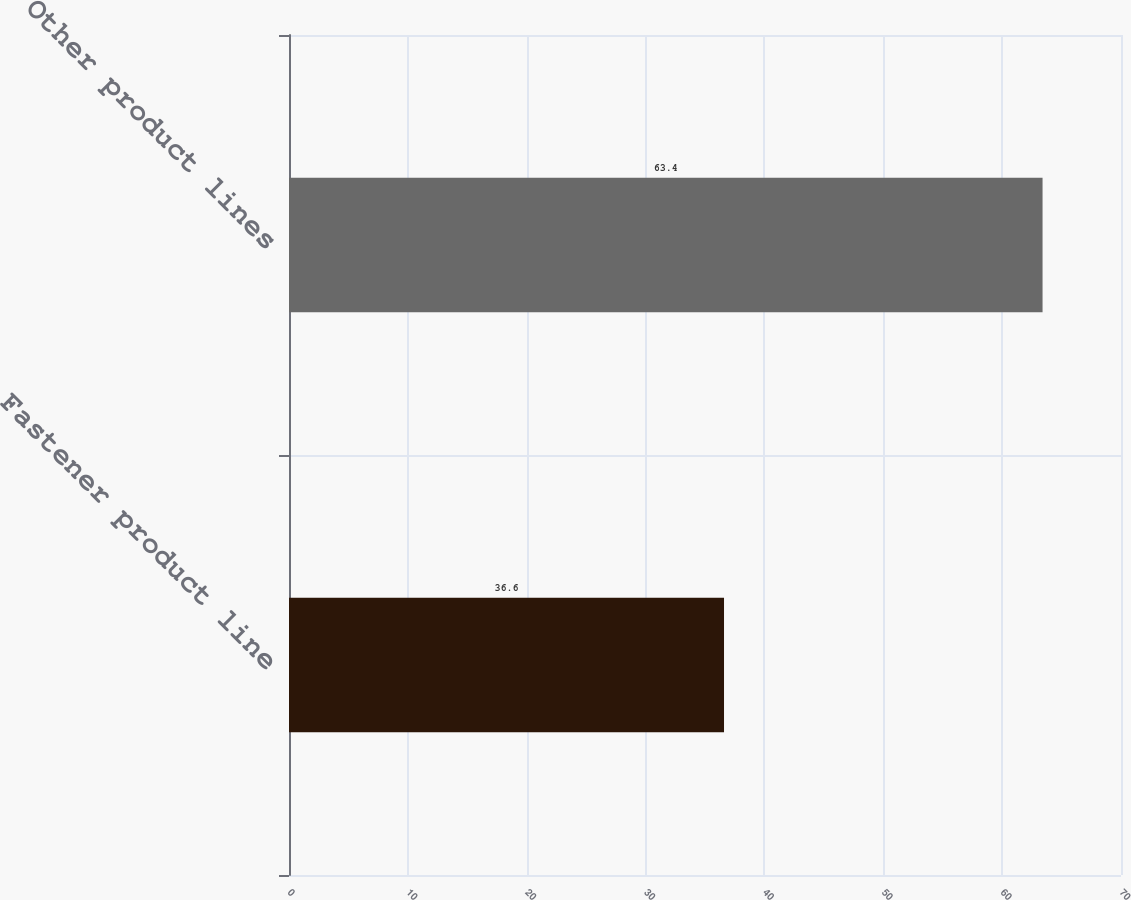Convert chart to OTSL. <chart><loc_0><loc_0><loc_500><loc_500><bar_chart><fcel>Fastener product line<fcel>Other product lines<nl><fcel>36.6<fcel>63.4<nl></chart> 